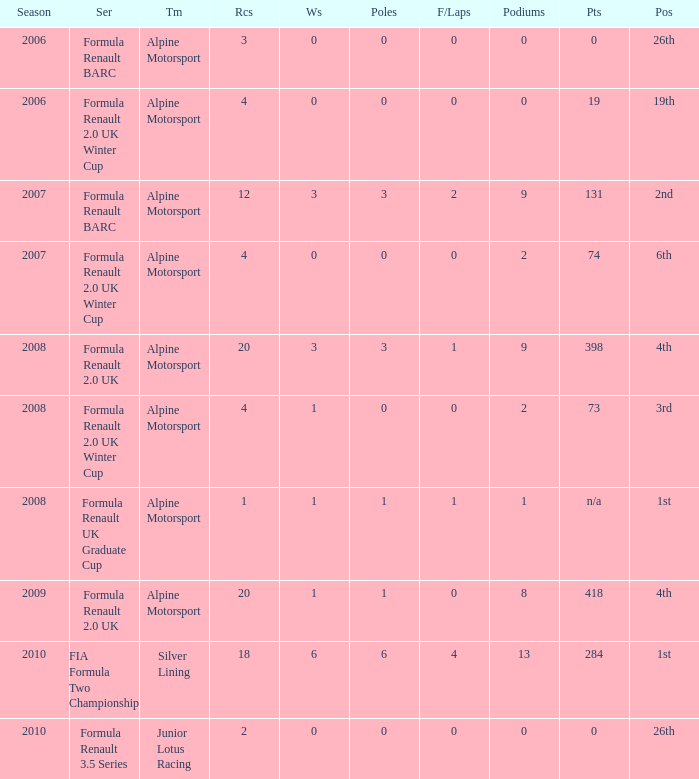What was the earliest season where podium was 9? 2007.0. 